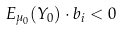Convert formula to latex. <formula><loc_0><loc_0><loc_500><loc_500>E _ { \mu _ { 0 } } ( Y _ { 0 } ) \cdot b _ { i } < 0</formula> 